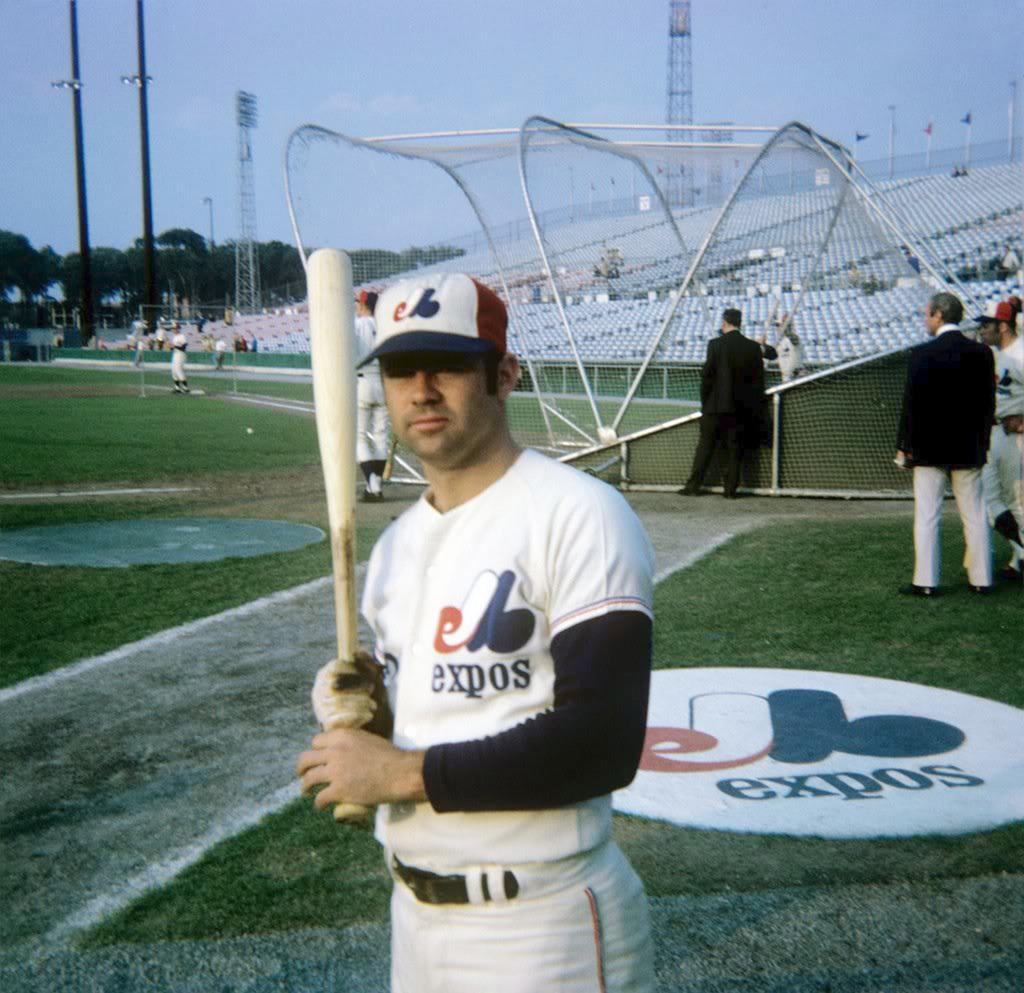<image>
Create a compact narrative representing the image presented. A baseball player on a field is holding a bat and his uniform says expos. 